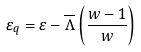Convert formula to latex. <formula><loc_0><loc_0><loc_500><loc_500>\varepsilon _ { q } = \varepsilon - \overline { \Lambda } \left ( \frac { w - 1 } { w } \right )</formula> 